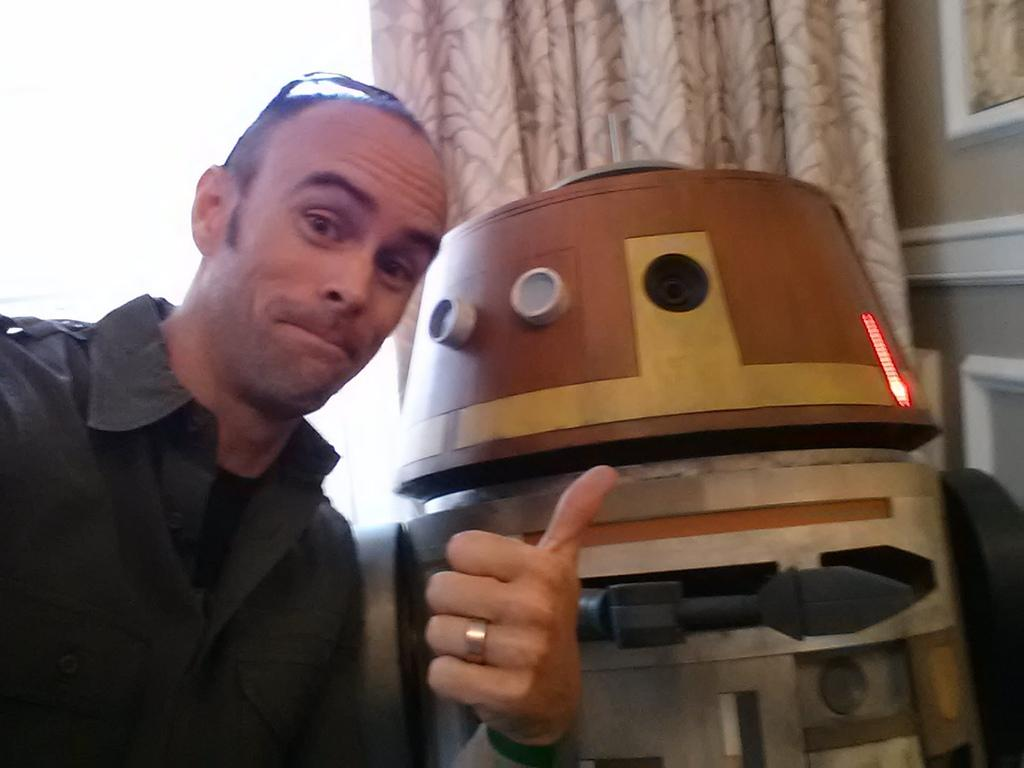Who or what is located in the left corner of the image? There is a person in the left corner of the image. What is beside the person in the image? There is an object beside the person in the image. What can be seen in the background of the image? There is a curtain in the background of the image. What type of insurance does the person in the image have? There is no information about insurance in the image, as it focuses on the person, an object beside them, and a curtain in the background. 